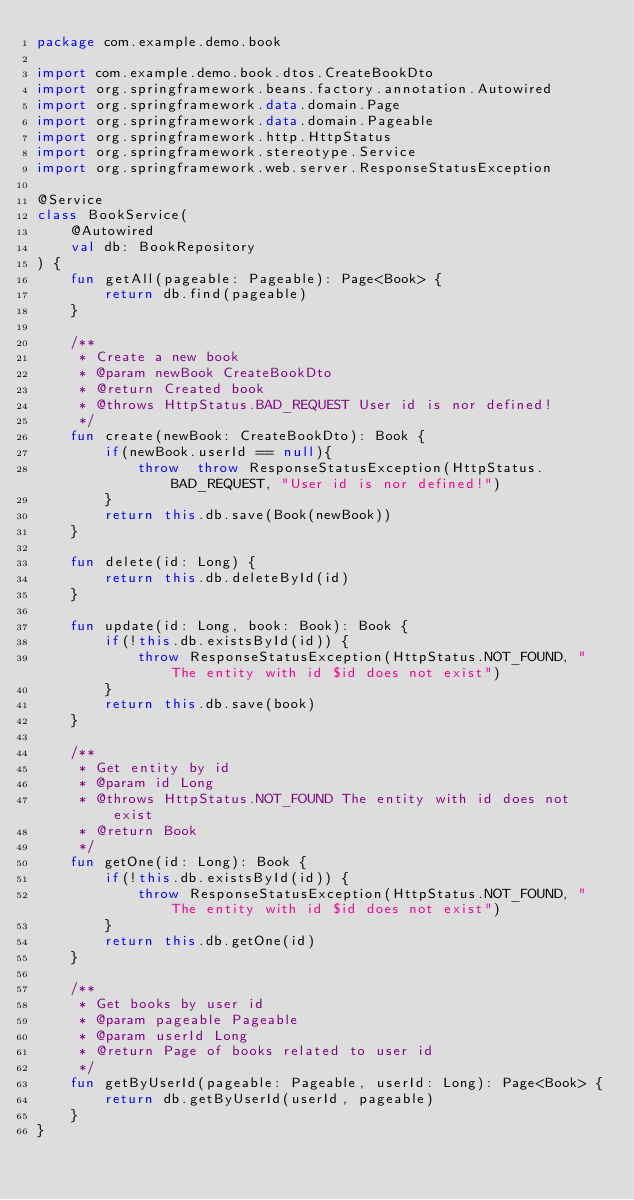Convert code to text. <code><loc_0><loc_0><loc_500><loc_500><_Kotlin_>package com.example.demo.book

import com.example.demo.book.dtos.CreateBookDto
import org.springframework.beans.factory.annotation.Autowired
import org.springframework.data.domain.Page
import org.springframework.data.domain.Pageable
import org.springframework.http.HttpStatus
import org.springframework.stereotype.Service
import org.springframework.web.server.ResponseStatusException

@Service
class BookService(
    @Autowired
    val db: BookRepository
) {
    fun getAll(pageable: Pageable): Page<Book> {
        return db.find(pageable)
    }

    /**
     * Create a new book
     * @param newBook CreateBookDto
     * @return Created book
     * @throws HttpStatus.BAD_REQUEST User id is nor defined!
     */
    fun create(newBook: CreateBookDto): Book {
        if(newBook.userId == null){
            throw  throw ResponseStatusException(HttpStatus.BAD_REQUEST, "User id is nor defined!")
        }
        return this.db.save(Book(newBook))
    }

    fun delete(id: Long) {
        return this.db.deleteById(id)
    }

    fun update(id: Long, book: Book): Book {
        if(!this.db.existsById(id)) {
            throw ResponseStatusException(HttpStatus.NOT_FOUND, "The entity with id $id does not exist")
        }
        return this.db.save(book)
    }

    /**
     * Get entity by id
     * @param id Long
     * @throws HttpStatus.NOT_FOUND The entity with id does not exist
     * @return Book
     */
    fun getOne(id: Long): Book {
        if(!this.db.existsById(id)) {
            throw ResponseStatusException(HttpStatus.NOT_FOUND, "The entity with id $id does not exist")
        }
        return this.db.getOne(id)
    }

    /**
     * Get books by user id
     * @param pageable Pageable
     * @param userId Long
     * @return Page of books related to user id
     */
    fun getByUserId(pageable: Pageable, userId: Long): Page<Book> {
        return db.getByUserId(userId, pageable)
    }
}</code> 